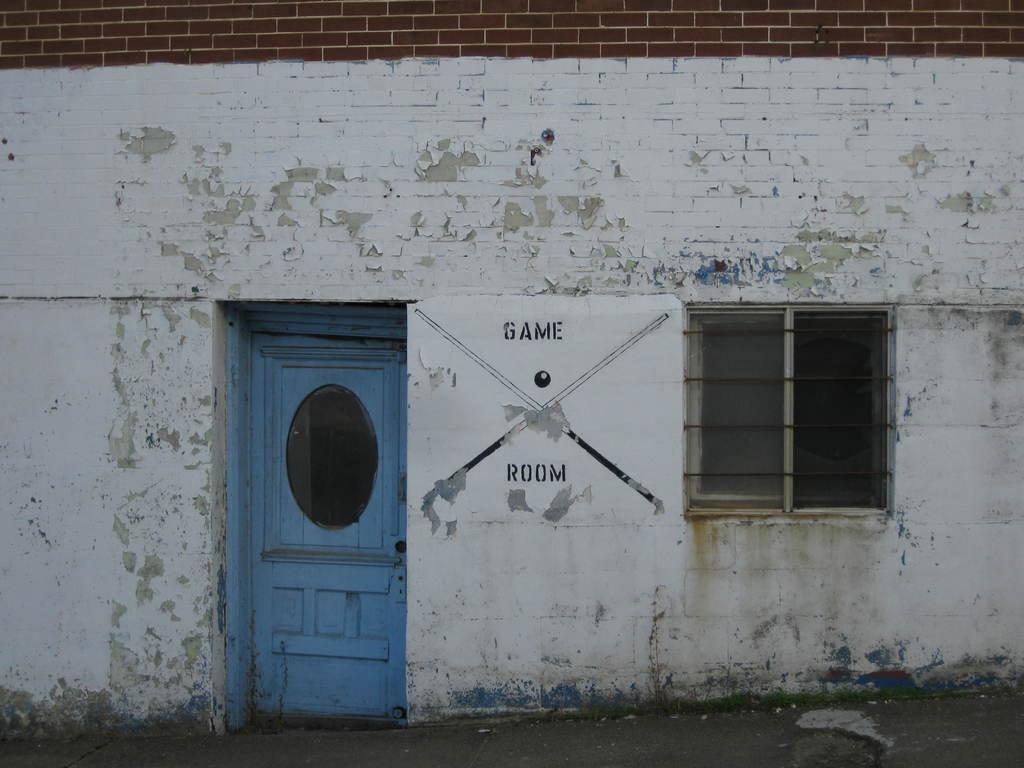Describe this image in one or two sentences. In this picture I can see a wall with a door, window and there is a poster attached to the wall. 